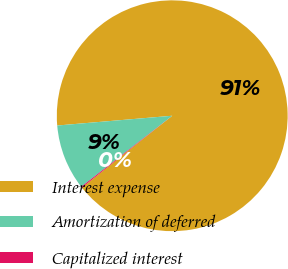<chart> <loc_0><loc_0><loc_500><loc_500><pie_chart><fcel>Interest expense<fcel>Amortization of deferred<fcel>Capitalized interest<nl><fcel>90.65%<fcel>9.2%<fcel>0.15%<nl></chart> 